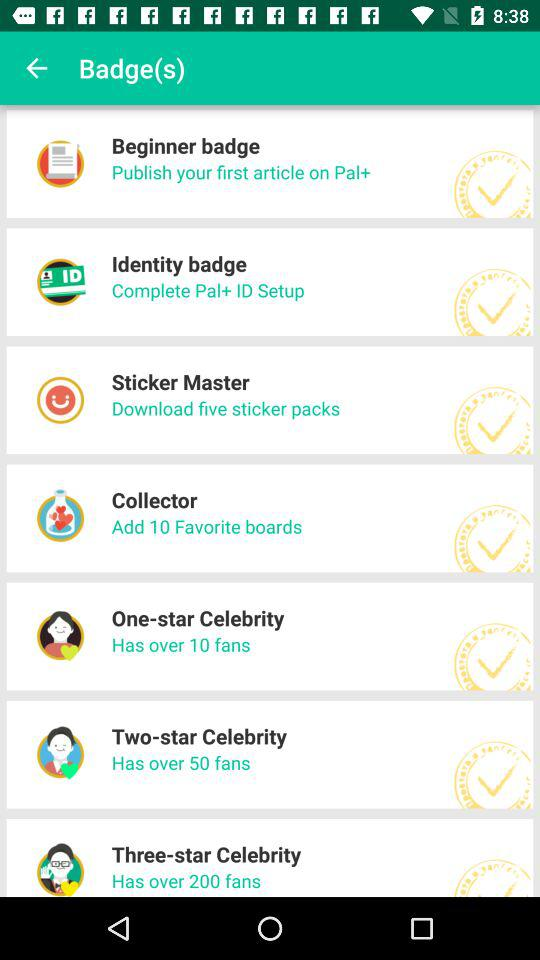Which option is given in the collector badge? The option is given in the collector badge to add 10 favorite boards. 